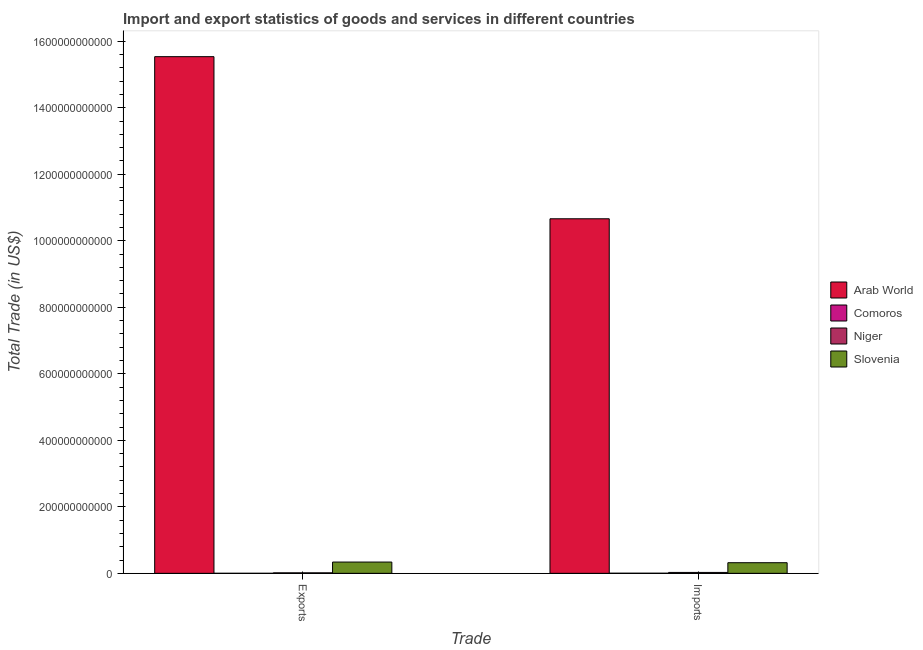How many groups of bars are there?
Give a very brief answer. 2. Are the number of bars per tick equal to the number of legend labels?
Give a very brief answer. Yes. Are the number of bars on each tick of the X-axis equal?
Your answer should be very brief. Yes. How many bars are there on the 2nd tick from the right?
Ensure brevity in your answer.  4. What is the label of the 1st group of bars from the left?
Offer a terse response. Exports. What is the imports of goods and services in Slovenia?
Make the answer very short. 3.19e+1. Across all countries, what is the maximum export of goods and services?
Provide a short and direct response. 1.55e+12. Across all countries, what is the minimum export of goods and services?
Ensure brevity in your answer.  8.89e+07. In which country was the imports of goods and services maximum?
Your answer should be very brief. Arab World. In which country was the export of goods and services minimum?
Your answer should be compact. Comoros. What is the total export of goods and services in the graph?
Offer a terse response. 1.59e+12. What is the difference between the export of goods and services in Comoros and that in Niger?
Provide a short and direct response. -1.43e+09. What is the difference between the export of goods and services in Slovenia and the imports of goods and services in Comoros?
Your answer should be compact. 3.36e+1. What is the average imports of goods and services per country?
Your answer should be very brief. 2.75e+11. What is the difference between the export of goods and services and imports of goods and services in Slovenia?
Keep it short and to the point. 1.96e+09. What is the ratio of the imports of goods and services in Arab World to that in Niger?
Your answer should be very brief. 390.18. Is the imports of goods and services in Arab World less than that in Niger?
Offer a terse response. No. What does the 1st bar from the left in Exports represents?
Give a very brief answer. Arab World. What does the 4th bar from the right in Exports represents?
Offer a terse response. Arab World. How many countries are there in the graph?
Offer a very short reply. 4. What is the difference between two consecutive major ticks on the Y-axis?
Your answer should be very brief. 2.00e+11. Are the values on the major ticks of Y-axis written in scientific E-notation?
Give a very brief answer. No. Where does the legend appear in the graph?
Your answer should be very brief. Center right. How many legend labels are there?
Offer a very short reply. 4. What is the title of the graph?
Keep it short and to the point. Import and export statistics of goods and services in different countries. Does "Andorra" appear as one of the legend labels in the graph?
Offer a very short reply. No. What is the label or title of the X-axis?
Give a very brief answer. Trade. What is the label or title of the Y-axis?
Your answer should be compact. Total Trade (in US$). What is the Total Trade (in US$) in Arab World in Exports?
Offer a terse response. 1.55e+12. What is the Total Trade (in US$) of Comoros in Exports?
Provide a succinct answer. 8.89e+07. What is the Total Trade (in US$) of Niger in Exports?
Ensure brevity in your answer.  1.52e+09. What is the Total Trade (in US$) of Slovenia in Exports?
Offer a terse response. 3.39e+1. What is the Total Trade (in US$) in Arab World in Imports?
Your response must be concise. 1.07e+12. What is the Total Trade (in US$) in Comoros in Imports?
Your answer should be compact. 3.21e+08. What is the Total Trade (in US$) of Niger in Imports?
Give a very brief answer. 2.73e+09. What is the Total Trade (in US$) in Slovenia in Imports?
Make the answer very short. 3.19e+1. Across all Trade, what is the maximum Total Trade (in US$) in Arab World?
Offer a terse response. 1.55e+12. Across all Trade, what is the maximum Total Trade (in US$) in Comoros?
Your answer should be very brief. 3.21e+08. Across all Trade, what is the maximum Total Trade (in US$) in Niger?
Give a very brief answer. 2.73e+09. Across all Trade, what is the maximum Total Trade (in US$) in Slovenia?
Your answer should be compact. 3.39e+1. Across all Trade, what is the minimum Total Trade (in US$) in Arab World?
Keep it short and to the point. 1.07e+12. Across all Trade, what is the minimum Total Trade (in US$) in Comoros?
Make the answer very short. 8.89e+07. Across all Trade, what is the minimum Total Trade (in US$) in Niger?
Ensure brevity in your answer.  1.52e+09. Across all Trade, what is the minimum Total Trade (in US$) in Slovenia?
Your response must be concise. 3.19e+1. What is the total Total Trade (in US$) of Arab World in the graph?
Offer a very short reply. 2.62e+12. What is the total Total Trade (in US$) in Comoros in the graph?
Your answer should be very brief. 4.10e+08. What is the total Total Trade (in US$) of Niger in the graph?
Offer a terse response. 4.25e+09. What is the total Total Trade (in US$) of Slovenia in the graph?
Offer a very short reply. 6.58e+1. What is the difference between the Total Trade (in US$) in Arab World in Exports and that in Imports?
Make the answer very short. 4.87e+11. What is the difference between the Total Trade (in US$) in Comoros in Exports and that in Imports?
Make the answer very short. -2.33e+08. What is the difference between the Total Trade (in US$) in Niger in Exports and that in Imports?
Provide a succinct answer. -1.22e+09. What is the difference between the Total Trade (in US$) of Slovenia in Exports and that in Imports?
Give a very brief answer. 1.96e+09. What is the difference between the Total Trade (in US$) of Arab World in Exports and the Total Trade (in US$) of Comoros in Imports?
Give a very brief answer. 1.55e+12. What is the difference between the Total Trade (in US$) of Arab World in Exports and the Total Trade (in US$) of Niger in Imports?
Offer a very short reply. 1.55e+12. What is the difference between the Total Trade (in US$) in Arab World in Exports and the Total Trade (in US$) in Slovenia in Imports?
Provide a short and direct response. 1.52e+12. What is the difference between the Total Trade (in US$) in Comoros in Exports and the Total Trade (in US$) in Niger in Imports?
Make the answer very short. -2.64e+09. What is the difference between the Total Trade (in US$) of Comoros in Exports and the Total Trade (in US$) of Slovenia in Imports?
Your answer should be compact. -3.19e+1. What is the difference between the Total Trade (in US$) of Niger in Exports and the Total Trade (in US$) of Slovenia in Imports?
Ensure brevity in your answer.  -3.04e+1. What is the average Total Trade (in US$) of Arab World per Trade?
Your answer should be very brief. 1.31e+12. What is the average Total Trade (in US$) in Comoros per Trade?
Your answer should be very brief. 2.05e+08. What is the average Total Trade (in US$) of Niger per Trade?
Your answer should be compact. 2.13e+09. What is the average Total Trade (in US$) in Slovenia per Trade?
Ensure brevity in your answer.  3.29e+1. What is the difference between the Total Trade (in US$) in Arab World and Total Trade (in US$) in Comoros in Exports?
Make the answer very short. 1.55e+12. What is the difference between the Total Trade (in US$) in Arab World and Total Trade (in US$) in Niger in Exports?
Provide a succinct answer. 1.55e+12. What is the difference between the Total Trade (in US$) of Arab World and Total Trade (in US$) of Slovenia in Exports?
Keep it short and to the point. 1.52e+12. What is the difference between the Total Trade (in US$) in Comoros and Total Trade (in US$) in Niger in Exports?
Offer a terse response. -1.43e+09. What is the difference between the Total Trade (in US$) in Comoros and Total Trade (in US$) in Slovenia in Exports?
Your answer should be compact. -3.38e+1. What is the difference between the Total Trade (in US$) of Niger and Total Trade (in US$) of Slovenia in Exports?
Your answer should be very brief. -3.24e+1. What is the difference between the Total Trade (in US$) of Arab World and Total Trade (in US$) of Comoros in Imports?
Your answer should be very brief. 1.07e+12. What is the difference between the Total Trade (in US$) in Arab World and Total Trade (in US$) in Niger in Imports?
Ensure brevity in your answer.  1.06e+12. What is the difference between the Total Trade (in US$) in Arab World and Total Trade (in US$) in Slovenia in Imports?
Give a very brief answer. 1.03e+12. What is the difference between the Total Trade (in US$) of Comoros and Total Trade (in US$) of Niger in Imports?
Give a very brief answer. -2.41e+09. What is the difference between the Total Trade (in US$) in Comoros and Total Trade (in US$) in Slovenia in Imports?
Provide a short and direct response. -3.16e+1. What is the difference between the Total Trade (in US$) in Niger and Total Trade (in US$) in Slovenia in Imports?
Give a very brief answer. -2.92e+1. What is the ratio of the Total Trade (in US$) of Arab World in Exports to that in Imports?
Give a very brief answer. 1.46. What is the ratio of the Total Trade (in US$) of Comoros in Exports to that in Imports?
Provide a succinct answer. 0.28. What is the ratio of the Total Trade (in US$) in Niger in Exports to that in Imports?
Make the answer very short. 0.56. What is the ratio of the Total Trade (in US$) of Slovenia in Exports to that in Imports?
Give a very brief answer. 1.06. What is the difference between the highest and the second highest Total Trade (in US$) of Arab World?
Make the answer very short. 4.87e+11. What is the difference between the highest and the second highest Total Trade (in US$) in Comoros?
Offer a terse response. 2.33e+08. What is the difference between the highest and the second highest Total Trade (in US$) in Niger?
Keep it short and to the point. 1.22e+09. What is the difference between the highest and the second highest Total Trade (in US$) of Slovenia?
Offer a very short reply. 1.96e+09. What is the difference between the highest and the lowest Total Trade (in US$) in Arab World?
Make the answer very short. 4.87e+11. What is the difference between the highest and the lowest Total Trade (in US$) of Comoros?
Your response must be concise. 2.33e+08. What is the difference between the highest and the lowest Total Trade (in US$) of Niger?
Offer a terse response. 1.22e+09. What is the difference between the highest and the lowest Total Trade (in US$) of Slovenia?
Make the answer very short. 1.96e+09. 